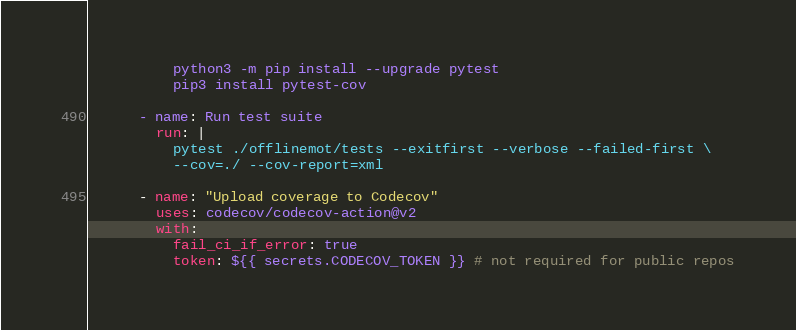Convert code to text. <code><loc_0><loc_0><loc_500><loc_500><_YAML_>          python3 -m pip install --upgrade pytest
          pip3 install pytest-cov

      - name: Run test suite
        run: |
          pytest ./offlinemot/tests --exitfirst --verbose --failed-first \
          --cov=./ --cov-report=xml

      - name: "Upload coverage to Codecov"
        uses: codecov/codecov-action@v2
        with:
          fail_ci_if_error: true
          token: ${{ secrets.CODECOV_TOKEN }} # not required for public repos</code> 